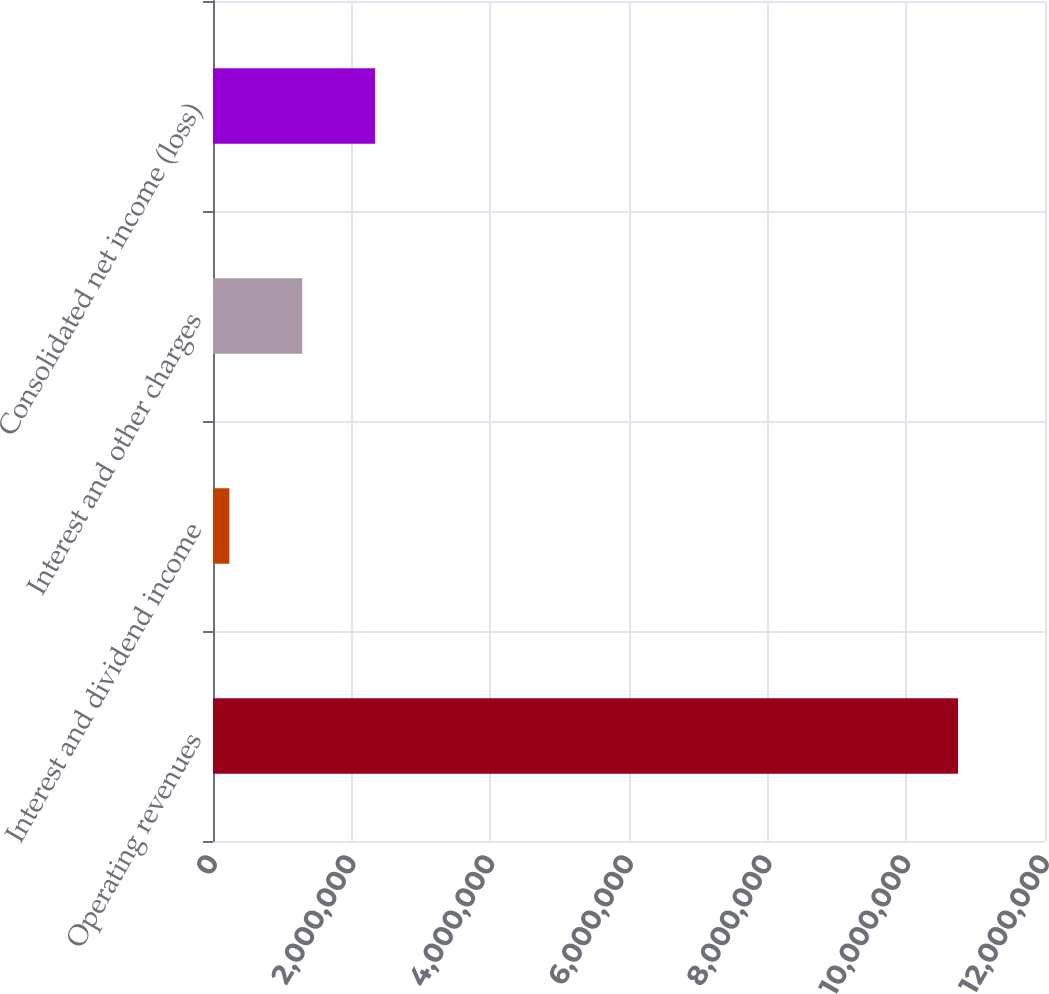Convert chart. <chart><loc_0><loc_0><loc_500><loc_500><bar_chart><fcel>Operating revenues<fcel>Interest and dividend income<fcel>Interest and other charges<fcel>Consolidated net income (loss)<nl><fcel>1.07456e+07<fcel>236628<fcel>1.28753e+06<fcel>2.33843e+06<nl></chart> 